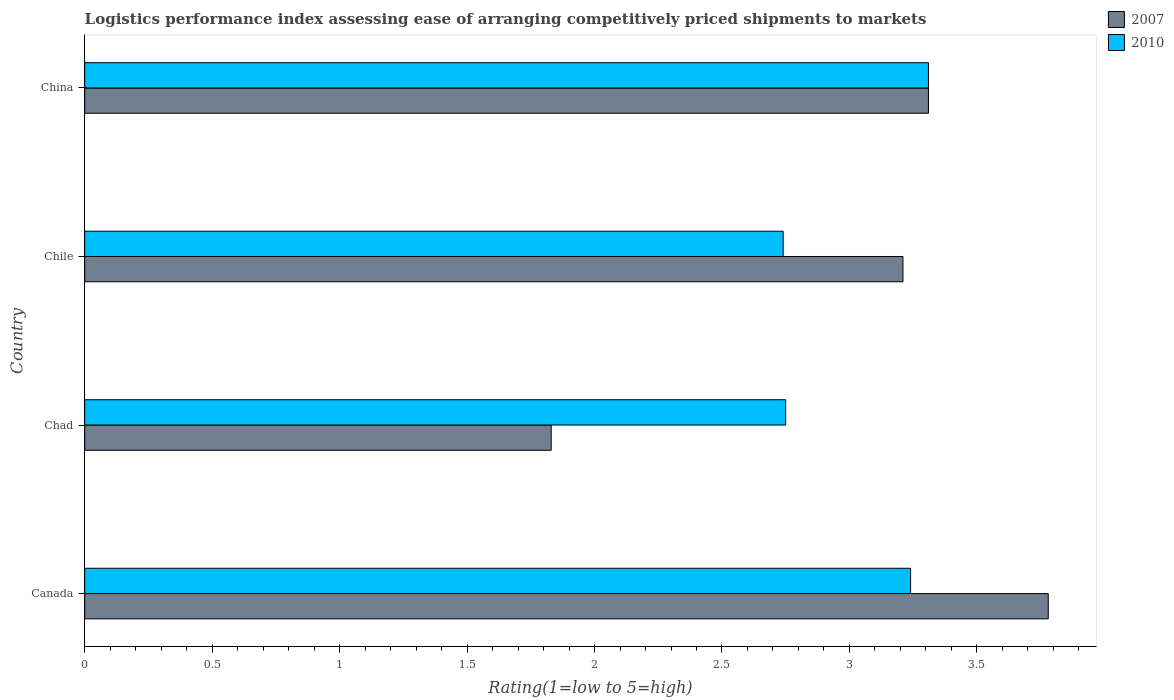How many different coloured bars are there?
Make the answer very short. 2. How many groups of bars are there?
Your answer should be very brief. 4. Are the number of bars per tick equal to the number of legend labels?
Ensure brevity in your answer.  Yes. What is the Logistic performance index in 2007 in Canada?
Offer a terse response. 3.78. Across all countries, what is the maximum Logistic performance index in 2010?
Give a very brief answer. 3.31. Across all countries, what is the minimum Logistic performance index in 2010?
Make the answer very short. 2.74. In which country was the Logistic performance index in 2007 minimum?
Your answer should be very brief. Chad. What is the total Logistic performance index in 2010 in the graph?
Make the answer very short. 12.04. What is the difference between the Logistic performance index in 2010 in Chad and that in China?
Your answer should be compact. -0.56. What is the difference between the Logistic performance index in 2010 in Chad and the Logistic performance index in 2007 in China?
Make the answer very short. -0.56. What is the average Logistic performance index in 2010 per country?
Give a very brief answer. 3.01. What is the difference between the Logistic performance index in 2010 and Logistic performance index in 2007 in Canada?
Provide a short and direct response. -0.54. In how many countries, is the Logistic performance index in 2007 greater than 2.5 ?
Offer a terse response. 3. What is the ratio of the Logistic performance index in 2007 in Canada to that in Chad?
Ensure brevity in your answer.  2.07. What is the difference between the highest and the second highest Logistic performance index in 2007?
Provide a short and direct response. 0.47. What is the difference between the highest and the lowest Logistic performance index in 2010?
Your answer should be compact. 0.57. In how many countries, is the Logistic performance index in 2007 greater than the average Logistic performance index in 2007 taken over all countries?
Give a very brief answer. 3. What does the 1st bar from the top in Chad represents?
Give a very brief answer. 2010. What does the 2nd bar from the bottom in Canada represents?
Provide a succinct answer. 2010. Are all the bars in the graph horizontal?
Make the answer very short. Yes. What is the difference between two consecutive major ticks on the X-axis?
Your answer should be compact. 0.5. Are the values on the major ticks of X-axis written in scientific E-notation?
Make the answer very short. No. Does the graph contain any zero values?
Make the answer very short. No. Does the graph contain grids?
Provide a short and direct response. No. Where does the legend appear in the graph?
Offer a terse response. Top right. What is the title of the graph?
Give a very brief answer. Logistics performance index assessing ease of arranging competitively priced shipments to markets. Does "1983" appear as one of the legend labels in the graph?
Provide a succinct answer. No. What is the label or title of the X-axis?
Make the answer very short. Rating(1=low to 5=high). What is the Rating(1=low to 5=high) in 2007 in Canada?
Make the answer very short. 3.78. What is the Rating(1=low to 5=high) in 2010 in Canada?
Provide a succinct answer. 3.24. What is the Rating(1=low to 5=high) in 2007 in Chad?
Your answer should be compact. 1.83. What is the Rating(1=low to 5=high) of 2010 in Chad?
Provide a short and direct response. 2.75. What is the Rating(1=low to 5=high) in 2007 in Chile?
Give a very brief answer. 3.21. What is the Rating(1=low to 5=high) of 2010 in Chile?
Your answer should be very brief. 2.74. What is the Rating(1=low to 5=high) in 2007 in China?
Make the answer very short. 3.31. What is the Rating(1=low to 5=high) of 2010 in China?
Give a very brief answer. 3.31. Across all countries, what is the maximum Rating(1=low to 5=high) in 2007?
Give a very brief answer. 3.78. Across all countries, what is the maximum Rating(1=low to 5=high) in 2010?
Provide a short and direct response. 3.31. Across all countries, what is the minimum Rating(1=low to 5=high) in 2007?
Your answer should be very brief. 1.83. Across all countries, what is the minimum Rating(1=low to 5=high) in 2010?
Ensure brevity in your answer.  2.74. What is the total Rating(1=low to 5=high) in 2007 in the graph?
Provide a succinct answer. 12.13. What is the total Rating(1=low to 5=high) of 2010 in the graph?
Offer a terse response. 12.04. What is the difference between the Rating(1=low to 5=high) in 2007 in Canada and that in Chad?
Your answer should be compact. 1.95. What is the difference between the Rating(1=low to 5=high) in 2010 in Canada and that in Chad?
Your response must be concise. 0.49. What is the difference between the Rating(1=low to 5=high) in 2007 in Canada and that in Chile?
Give a very brief answer. 0.57. What is the difference between the Rating(1=low to 5=high) of 2007 in Canada and that in China?
Provide a succinct answer. 0.47. What is the difference between the Rating(1=low to 5=high) in 2010 in Canada and that in China?
Make the answer very short. -0.07. What is the difference between the Rating(1=low to 5=high) in 2007 in Chad and that in Chile?
Your response must be concise. -1.38. What is the difference between the Rating(1=low to 5=high) of 2007 in Chad and that in China?
Your answer should be compact. -1.48. What is the difference between the Rating(1=low to 5=high) in 2010 in Chad and that in China?
Give a very brief answer. -0.56. What is the difference between the Rating(1=low to 5=high) of 2007 in Chile and that in China?
Provide a succinct answer. -0.1. What is the difference between the Rating(1=low to 5=high) of 2010 in Chile and that in China?
Make the answer very short. -0.57. What is the difference between the Rating(1=low to 5=high) of 2007 in Canada and the Rating(1=low to 5=high) of 2010 in China?
Your answer should be compact. 0.47. What is the difference between the Rating(1=low to 5=high) of 2007 in Chad and the Rating(1=low to 5=high) of 2010 in Chile?
Offer a very short reply. -0.91. What is the difference between the Rating(1=low to 5=high) of 2007 in Chad and the Rating(1=low to 5=high) of 2010 in China?
Provide a succinct answer. -1.48. What is the average Rating(1=low to 5=high) of 2007 per country?
Offer a very short reply. 3.03. What is the average Rating(1=low to 5=high) of 2010 per country?
Offer a very short reply. 3.01. What is the difference between the Rating(1=low to 5=high) of 2007 and Rating(1=low to 5=high) of 2010 in Canada?
Your answer should be compact. 0.54. What is the difference between the Rating(1=low to 5=high) in 2007 and Rating(1=low to 5=high) in 2010 in Chad?
Your answer should be compact. -0.92. What is the difference between the Rating(1=low to 5=high) in 2007 and Rating(1=low to 5=high) in 2010 in Chile?
Make the answer very short. 0.47. What is the difference between the Rating(1=low to 5=high) of 2007 and Rating(1=low to 5=high) of 2010 in China?
Offer a terse response. 0. What is the ratio of the Rating(1=low to 5=high) of 2007 in Canada to that in Chad?
Make the answer very short. 2.07. What is the ratio of the Rating(1=low to 5=high) in 2010 in Canada to that in Chad?
Offer a very short reply. 1.18. What is the ratio of the Rating(1=low to 5=high) in 2007 in Canada to that in Chile?
Ensure brevity in your answer.  1.18. What is the ratio of the Rating(1=low to 5=high) in 2010 in Canada to that in Chile?
Your answer should be compact. 1.18. What is the ratio of the Rating(1=low to 5=high) of 2007 in Canada to that in China?
Provide a succinct answer. 1.14. What is the ratio of the Rating(1=low to 5=high) of 2010 in Canada to that in China?
Make the answer very short. 0.98. What is the ratio of the Rating(1=low to 5=high) in 2007 in Chad to that in Chile?
Provide a succinct answer. 0.57. What is the ratio of the Rating(1=low to 5=high) of 2007 in Chad to that in China?
Provide a succinct answer. 0.55. What is the ratio of the Rating(1=low to 5=high) of 2010 in Chad to that in China?
Your response must be concise. 0.83. What is the ratio of the Rating(1=low to 5=high) in 2007 in Chile to that in China?
Your answer should be compact. 0.97. What is the ratio of the Rating(1=low to 5=high) in 2010 in Chile to that in China?
Ensure brevity in your answer.  0.83. What is the difference between the highest and the second highest Rating(1=low to 5=high) of 2007?
Your answer should be compact. 0.47. What is the difference between the highest and the second highest Rating(1=low to 5=high) of 2010?
Offer a terse response. 0.07. What is the difference between the highest and the lowest Rating(1=low to 5=high) of 2007?
Make the answer very short. 1.95. What is the difference between the highest and the lowest Rating(1=low to 5=high) of 2010?
Make the answer very short. 0.57. 